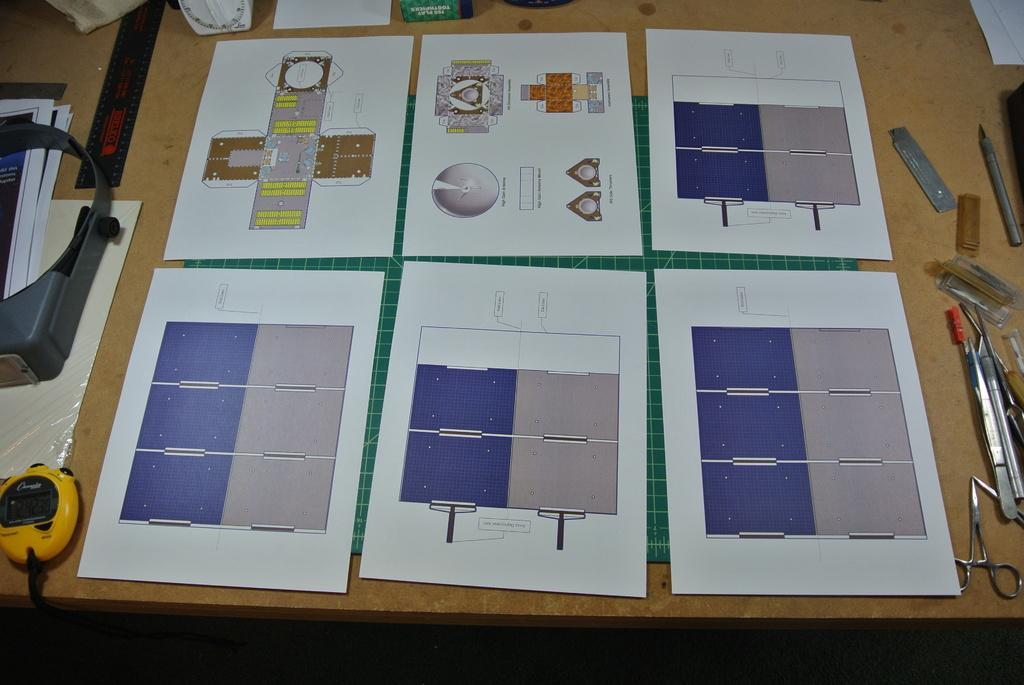What type of objects can be seen in the image? There are papers, scissors, and a cutting mat in the image. What might the papers be used for? The papers might be used for cutting or crafting, given the presence of scissors and a cutting mat. What other objects are on the table in the image? There are other objects on the table in the image, but their specific details are not mentioned in the provided facts. How many cherries are on the doctor's hat in the image? There are no cherries or doctors present in the image; it only features papers, scissors, and a cutting mat on a table. 